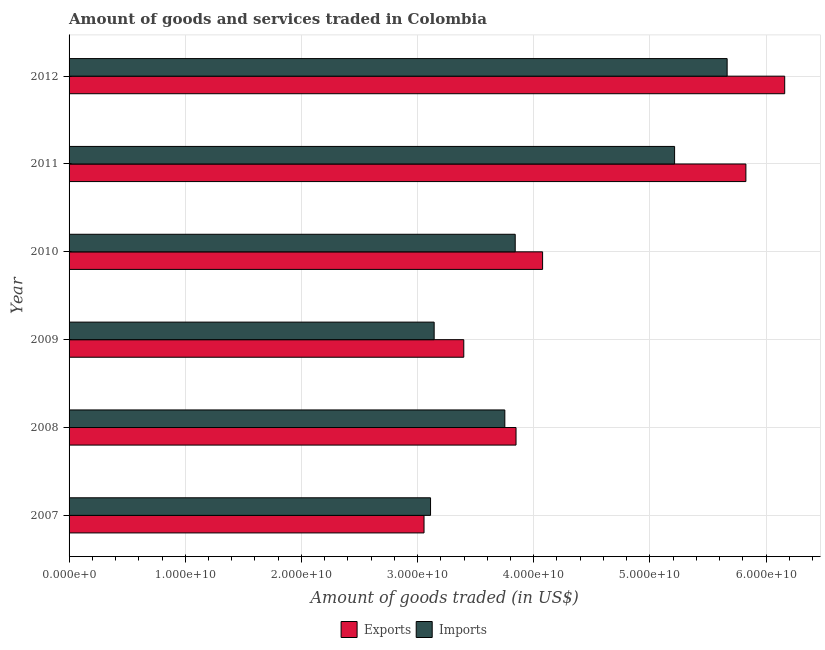Are the number of bars per tick equal to the number of legend labels?
Offer a very short reply. Yes. How many bars are there on the 2nd tick from the top?
Your answer should be very brief. 2. What is the label of the 1st group of bars from the top?
Ensure brevity in your answer.  2012. What is the amount of goods exported in 2009?
Offer a very short reply. 3.40e+1. Across all years, what is the maximum amount of goods imported?
Your answer should be compact. 5.66e+1. Across all years, what is the minimum amount of goods exported?
Provide a succinct answer. 3.06e+1. In which year was the amount of goods exported maximum?
Provide a succinct answer. 2012. In which year was the amount of goods imported minimum?
Offer a very short reply. 2007. What is the total amount of goods imported in the graph?
Give a very brief answer. 2.47e+11. What is the difference between the amount of goods imported in 2011 and that in 2012?
Offer a terse response. -4.52e+09. What is the difference between the amount of goods imported in 2010 and the amount of goods exported in 2007?
Give a very brief answer. 7.85e+09. What is the average amount of goods imported per year?
Provide a short and direct response. 4.12e+1. In the year 2008, what is the difference between the amount of goods exported and amount of goods imported?
Provide a succinct answer. 9.64e+08. In how many years, is the amount of goods imported greater than 16000000000 US$?
Your answer should be very brief. 6. What is the ratio of the amount of goods imported in 2010 to that in 2012?
Your answer should be compact. 0.68. Is the difference between the amount of goods exported in 2007 and 2010 greater than the difference between the amount of goods imported in 2007 and 2010?
Keep it short and to the point. No. What is the difference between the highest and the second highest amount of goods imported?
Your answer should be very brief. 4.52e+09. What is the difference between the highest and the lowest amount of goods imported?
Your response must be concise. 2.55e+1. What does the 2nd bar from the top in 2012 represents?
Offer a terse response. Exports. What does the 2nd bar from the bottom in 2011 represents?
Your response must be concise. Imports. Are all the bars in the graph horizontal?
Your response must be concise. Yes. Where does the legend appear in the graph?
Your answer should be compact. Bottom center. What is the title of the graph?
Your response must be concise. Amount of goods and services traded in Colombia. What is the label or title of the X-axis?
Offer a very short reply. Amount of goods traded (in US$). What is the Amount of goods traded (in US$) of Exports in 2007?
Offer a terse response. 3.06e+1. What is the Amount of goods traded (in US$) of Imports in 2007?
Offer a terse response. 3.11e+1. What is the Amount of goods traded (in US$) in Exports in 2008?
Offer a very short reply. 3.85e+1. What is the Amount of goods traded (in US$) in Imports in 2008?
Offer a terse response. 3.75e+1. What is the Amount of goods traded (in US$) in Exports in 2009?
Offer a very short reply. 3.40e+1. What is the Amount of goods traded (in US$) of Imports in 2009?
Offer a very short reply. 3.14e+1. What is the Amount of goods traded (in US$) in Exports in 2010?
Give a very brief answer. 4.08e+1. What is the Amount of goods traded (in US$) of Imports in 2010?
Your answer should be compact. 3.84e+1. What is the Amount of goods traded (in US$) of Exports in 2011?
Your answer should be very brief. 5.83e+1. What is the Amount of goods traded (in US$) of Imports in 2011?
Provide a short and direct response. 5.21e+1. What is the Amount of goods traded (in US$) of Exports in 2012?
Ensure brevity in your answer.  6.16e+1. What is the Amount of goods traded (in US$) of Imports in 2012?
Give a very brief answer. 5.66e+1. Across all years, what is the maximum Amount of goods traded (in US$) of Exports?
Offer a terse response. 6.16e+1. Across all years, what is the maximum Amount of goods traded (in US$) in Imports?
Keep it short and to the point. 5.66e+1. Across all years, what is the minimum Amount of goods traded (in US$) of Exports?
Provide a short and direct response. 3.06e+1. Across all years, what is the minimum Amount of goods traded (in US$) of Imports?
Provide a short and direct response. 3.11e+1. What is the total Amount of goods traded (in US$) in Exports in the graph?
Provide a short and direct response. 2.64e+11. What is the total Amount of goods traded (in US$) of Imports in the graph?
Ensure brevity in your answer.  2.47e+11. What is the difference between the Amount of goods traded (in US$) in Exports in 2007 and that in 2008?
Ensure brevity in your answer.  -7.92e+09. What is the difference between the Amount of goods traded (in US$) in Imports in 2007 and that in 2008?
Your response must be concise. -6.40e+09. What is the difference between the Amount of goods traded (in US$) in Exports in 2007 and that in 2009?
Your response must be concise. -3.42e+09. What is the difference between the Amount of goods traded (in US$) of Imports in 2007 and that in 2009?
Make the answer very short. -3.12e+08. What is the difference between the Amount of goods traded (in US$) of Exports in 2007 and that in 2010?
Your response must be concise. -1.02e+1. What is the difference between the Amount of goods traded (in US$) of Imports in 2007 and that in 2010?
Provide a short and direct response. -7.29e+09. What is the difference between the Amount of goods traded (in US$) of Exports in 2007 and that in 2011?
Your answer should be compact. -2.77e+1. What is the difference between the Amount of goods traded (in US$) in Imports in 2007 and that in 2011?
Make the answer very short. -2.10e+1. What is the difference between the Amount of goods traded (in US$) in Exports in 2007 and that in 2012?
Your response must be concise. -3.10e+1. What is the difference between the Amount of goods traded (in US$) in Imports in 2007 and that in 2012?
Provide a succinct answer. -2.55e+1. What is the difference between the Amount of goods traded (in US$) in Exports in 2008 and that in 2009?
Keep it short and to the point. 4.50e+09. What is the difference between the Amount of goods traded (in US$) in Imports in 2008 and that in 2009?
Provide a succinct answer. 6.08e+09. What is the difference between the Amount of goods traded (in US$) in Exports in 2008 and that in 2010?
Ensure brevity in your answer.  -2.29e+09. What is the difference between the Amount of goods traded (in US$) in Imports in 2008 and that in 2010?
Provide a short and direct response. -8.94e+08. What is the difference between the Amount of goods traded (in US$) in Exports in 2008 and that in 2011?
Offer a terse response. -1.98e+1. What is the difference between the Amount of goods traded (in US$) of Imports in 2008 and that in 2011?
Provide a short and direct response. -1.46e+1. What is the difference between the Amount of goods traded (in US$) in Exports in 2008 and that in 2012?
Make the answer very short. -2.31e+1. What is the difference between the Amount of goods traded (in US$) of Imports in 2008 and that in 2012?
Give a very brief answer. -1.91e+1. What is the difference between the Amount of goods traded (in US$) in Exports in 2009 and that in 2010?
Offer a terse response. -6.78e+09. What is the difference between the Amount of goods traded (in US$) of Imports in 2009 and that in 2010?
Your answer should be very brief. -6.98e+09. What is the difference between the Amount of goods traded (in US$) of Exports in 2009 and that in 2011?
Provide a succinct answer. -2.43e+1. What is the difference between the Amount of goods traded (in US$) in Imports in 2009 and that in 2011?
Offer a terse response. -2.07e+1. What is the difference between the Amount of goods traded (in US$) of Exports in 2009 and that in 2012?
Offer a terse response. -2.76e+1. What is the difference between the Amount of goods traded (in US$) of Imports in 2009 and that in 2012?
Offer a very short reply. -2.52e+1. What is the difference between the Amount of goods traded (in US$) of Exports in 2010 and that in 2011?
Keep it short and to the point. -1.75e+1. What is the difference between the Amount of goods traded (in US$) of Imports in 2010 and that in 2011?
Your answer should be very brief. -1.37e+1. What is the difference between the Amount of goods traded (in US$) in Exports in 2010 and that in 2012?
Provide a short and direct response. -2.08e+1. What is the difference between the Amount of goods traded (in US$) in Imports in 2010 and that in 2012?
Make the answer very short. -1.82e+1. What is the difference between the Amount of goods traded (in US$) in Exports in 2011 and that in 2012?
Make the answer very short. -3.34e+09. What is the difference between the Amount of goods traded (in US$) of Imports in 2011 and that in 2012?
Your response must be concise. -4.52e+09. What is the difference between the Amount of goods traded (in US$) in Exports in 2007 and the Amount of goods traded (in US$) in Imports in 2008?
Provide a short and direct response. -6.96e+09. What is the difference between the Amount of goods traded (in US$) of Exports in 2007 and the Amount of goods traded (in US$) of Imports in 2009?
Give a very brief answer. -8.72e+08. What is the difference between the Amount of goods traded (in US$) of Exports in 2007 and the Amount of goods traded (in US$) of Imports in 2010?
Keep it short and to the point. -7.85e+09. What is the difference between the Amount of goods traded (in US$) in Exports in 2007 and the Amount of goods traded (in US$) in Imports in 2011?
Your answer should be compact. -2.16e+1. What is the difference between the Amount of goods traded (in US$) of Exports in 2007 and the Amount of goods traded (in US$) of Imports in 2012?
Ensure brevity in your answer.  -2.61e+1. What is the difference between the Amount of goods traded (in US$) of Exports in 2008 and the Amount of goods traded (in US$) of Imports in 2009?
Ensure brevity in your answer.  7.05e+09. What is the difference between the Amount of goods traded (in US$) in Exports in 2008 and the Amount of goods traded (in US$) in Imports in 2010?
Offer a very short reply. 7.00e+07. What is the difference between the Amount of goods traded (in US$) in Exports in 2008 and the Amount of goods traded (in US$) in Imports in 2011?
Provide a short and direct response. -1.36e+1. What is the difference between the Amount of goods traded (in US$) of Exports in 2008 and the Amount of goods traded (in US$) of Imports in 2012?
Provide a short and direct response. -1.82e+1. What is the difference between the Amount of goods traded (in US$) in Exports in 2009 and the Amount of goods traded (in US$) in Imports in 2010?
Make the answer very short. -4.43e+09. What is the difference between the Amount of goods traded (in US$) in Exports in 2009 and the Amount of goods traded (in US$) in Imports in 2011?
Your answer should be compact. -1.81e+1. What is the difference between the Amount of goods traded (in US$) of Exports in 2009 and the Amount of goods traded (in US$) of Imports in 2012?
Make the answer very short. -2.27e+1. What is the difference between the Amount of goods traded (in US$) in Exports in 2010 and the Amount of goods traded (in US$) in Imports in 2011?
Your response must be concise. -1.14e+1. What is the difference between the Amount of goods traded (in US$) in Exports in 2010 and the Amount of goods traded (in US$) in Imports in 2012?
Your answer should be very brief. -1.59e+1. What is the difference between the Amount of goods traded (in US$) of Exports in 2011 and the Amount of goods traded (in US$) of Imports in 2012?
Keep it short and to the point. 1.61e+09. What is the average Amount of goods traded (in US$) in Exports per year?
Your answer should be compact. 4.39e+1. What is the average Amount of goods traded (in US$) in Imports per year?
Make the answer very short. 4.12e+1. In the year 2007, what is the difference between the Amount of goods traded (in US$) in Exports and Amount of goods traded (in US$) in Imports?
Give a very brief answer. -5.60e+08. In the year 2008, what is the difference between the Amount of goods traded (in US$) in Exports and Amount of goods traded (in US$) in Imports?
Keep it short and to the point. 9.64e+08. In the year 2009, what is the difference between the Amount of goods traded (in US$) of Exports and Amount of goods traded (in US$) of Imports?
Offer a very short reply. 2.55e+09. In the year 2010, what is the difference between the Amount of goods traded (in US$) in Exports and Amount of goods traded (in US$) in Imports?
Make the answer very short. 2.36e+09. In the year 2011, what is the difference between the Amount of goods traded (in US$) in Exports and Amount of goods traded (in US$) in Imports?
Provide a succinct answer. 6.14e+09. In the year 2012, what is the difference between the Amount of goods traded (in US$) of Exports and Amount of goods traded (in US$) of Imports?
Make the answer very short. 4.96e+09. What is the ratio of the Amount of goods traded (in US$) in Exports in 2007 to that in 2008?
Your answer should be very brief. 0.79. What is the ratio of the Amount of goods traded (in US$) of Imports in 2007 to that in 2008?
Offer a terse response. 0.83. What is the ratio of the Amount of goods traded (in US$) of Exports in 2007 to that in 2009?
Keep it short and to the point. 0.9. What is the ratio of the Amount of goods traded (in US$) of Imports in 2007 to that in 2009?
Offer a terse response. 0.99. What is the ratio of the Amount of goods traded (in US$) of Exports in 2007 to that in 2010?
Offer a terse response. 0.75. What is the ratio of the Amount of goods traded (in US$) of Imports in 2007 to that in 2010?
Give a very brief answer. 0.81. What is the ratio of the Amount of goods traded (in US$) in Exports in 2007 to that in 2011?
Offer a very short reply. 0.52. What is the ratio of the Amount of goods traded (in US$) of Imports in 2007 to that in 2011?
Provide a short and direct response. 0.6. What is the ratio of the Amount of goods traded (in US$) of Exports in 2007 to that in 2012?
Ensure brevity in your answer.  0.5. What is the ratio of the Amount of goods traded (in US$) in Imports in 2007 to that in 2012?
Offer a terse response. 0.55. What is the ratio of the Amount of goods traded (in US$) of Exports in 2008 to that in 2009?
Offer a very short reply. 1.13. What is the ratio of the Amount of goods traded (in US$) in Imports in 2008 to that in 2009?
Keep it short and to the point. 1.19. What is the ratio of the Amount of goods traded (in US$) in Exports in 2008 to that in 2010?
Your response must be concise. 0.94. What is the ratio of the Amount of goods traded (in US$) of Imports in 2008 to that in 2010?
Your response must be concise. 0.98. What is the ratio of the Amount of goods traded (in US$) of Exports in 2008 to that in 2011?
Keep it short and to the point. 0.66. What is the ratio of the Amount of goods traded (in US$) of Imports in 2008 to that in 2011?
Give a very brief answer. 0.72. What is the ratio of the Amount of goods traded (in US$) of Exports in 2008 to that in 2012?
Keep it short and to the point. 0.62. What is the ratio of the Amount of goods traded (in US$) in Imports in 2008 to that in 2012?
Offer a terse response. 0.66. What is the ratio of the Amount of goods traded (in US$) of Exports in 2009 to that in 2010?
Provide a short and direct response. 0.83. What is the ratio of the Amount of goods traded (in US$) of Imports in 2009 to that in 2010?
Your answer should be very brief. 0.82. What is the ratio of the Amount of goods traded (in US$) of Exports in 2009 to that in 2011?
Provide a succinct answer. 0.58. What is the ratio of the Amount of goods traded (in US$) of Imports in 2009 to that in 2011?
Offer a very short reply. 0.6. What is the ratio of the Amount of goods traded (in US$) of Exports in 2009 to that in 2012?
Provide a succinct answer. 0.55. What is the ratio of the Amount of goods traded (in US$) in Imports in 2009 to that in 2012?
Offer a terse response. 0.55. What is the ratio of the Amount of goods traded (in US$) in Exports in 2010 to that in 2011?
Give a very brief answer. 0.7. What is the ratio of the Amount of goods traded (in US$) of Imports in 2010 to that in 2011?
Ensure brevity in your answer.  0.74. What is the ratio of the Amount of goods traded (in US$) in Exports in 2010 to that in 2012?
Your answer should be very brief. 0.66. What is the ratio of the Amount of goods traded (in US$) of Imports in 2010 to that in 2012?
Your answer should be compact. 0.68. What is the ratio of the Amount of goods traded (in US$) in Exports in 2011 to that in 2012?
Offer a very short reply. 0.95. What is the ratio of the Amount of goods traded (in US$) in Imports in 2011 to that in 2012?
Your answer should be compact. 0.92. What is the difference between the highest and the second highest Amount of goods traded (in US$) of Exports?
Give a very brief answer. 3.34e+09. What is the difference between the highest and the second highest Amount of goods traded (in US$) of Imports?
Your answer should be very brief. 4.52e+09. What is the difference between the highest and the lowest Amount of goods traded (in US$) in Exports?
Your answer should be compact. 3.10e+1. What is the difference between the highest and the lowest Amount of goods traded (in US$) in Imports?
Your response must be concise. 2.55e+1. 